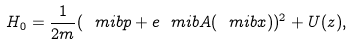<formula> <loc_0><loc_0><loc_500><loc_500>H _ { 0 } = \frac { 1 } { 2 m } ( \ m i b { p } + e \ m i b { A } ( \ m i b { x } ) ) ^ { 2 } + U ( z ) ,</formula> 